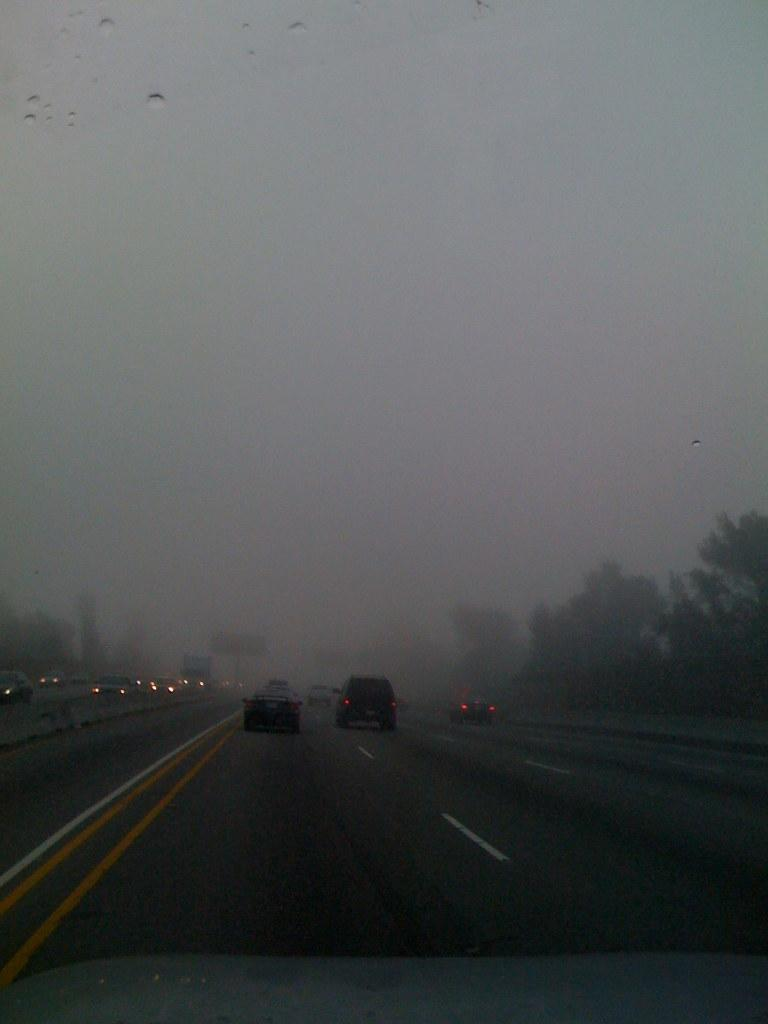What can be seen at the bottom of the image? There are vehicles on the road in the image. What is the location of the vehicles in the image? The vehicles are located at the bottom of the image. What type of natural scenery is visible in the background of the image? There are trees in the background of the image. What is visible at the top of the image? The sky is visible at the top of the image. What type of advertisement can be seen on the trees in the image? There are no advertisements visible on the trees in the image; only trees are present in the background. What type of vegetable is growing on the vehicles in the image? There are no vegetables growing on the vehicles in the image; the vehicles are on the road and not a garden. 